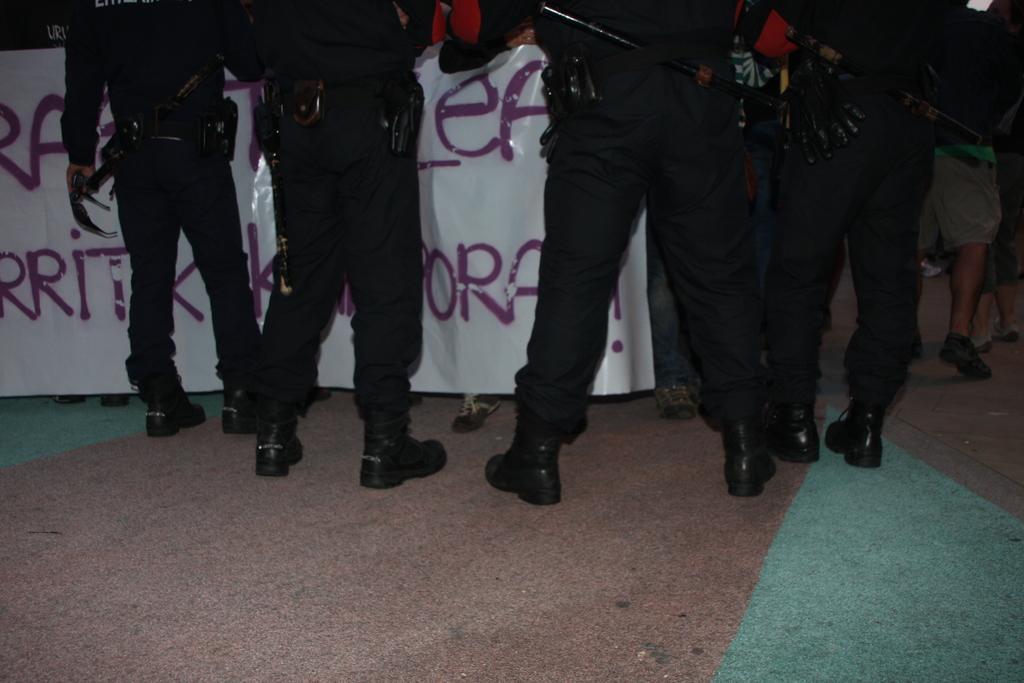Could you give a brief overview of what you see in this image? In this image I can see there are few persons visible in front of the banner , on the banner I can see text, persons visible on the floor. 